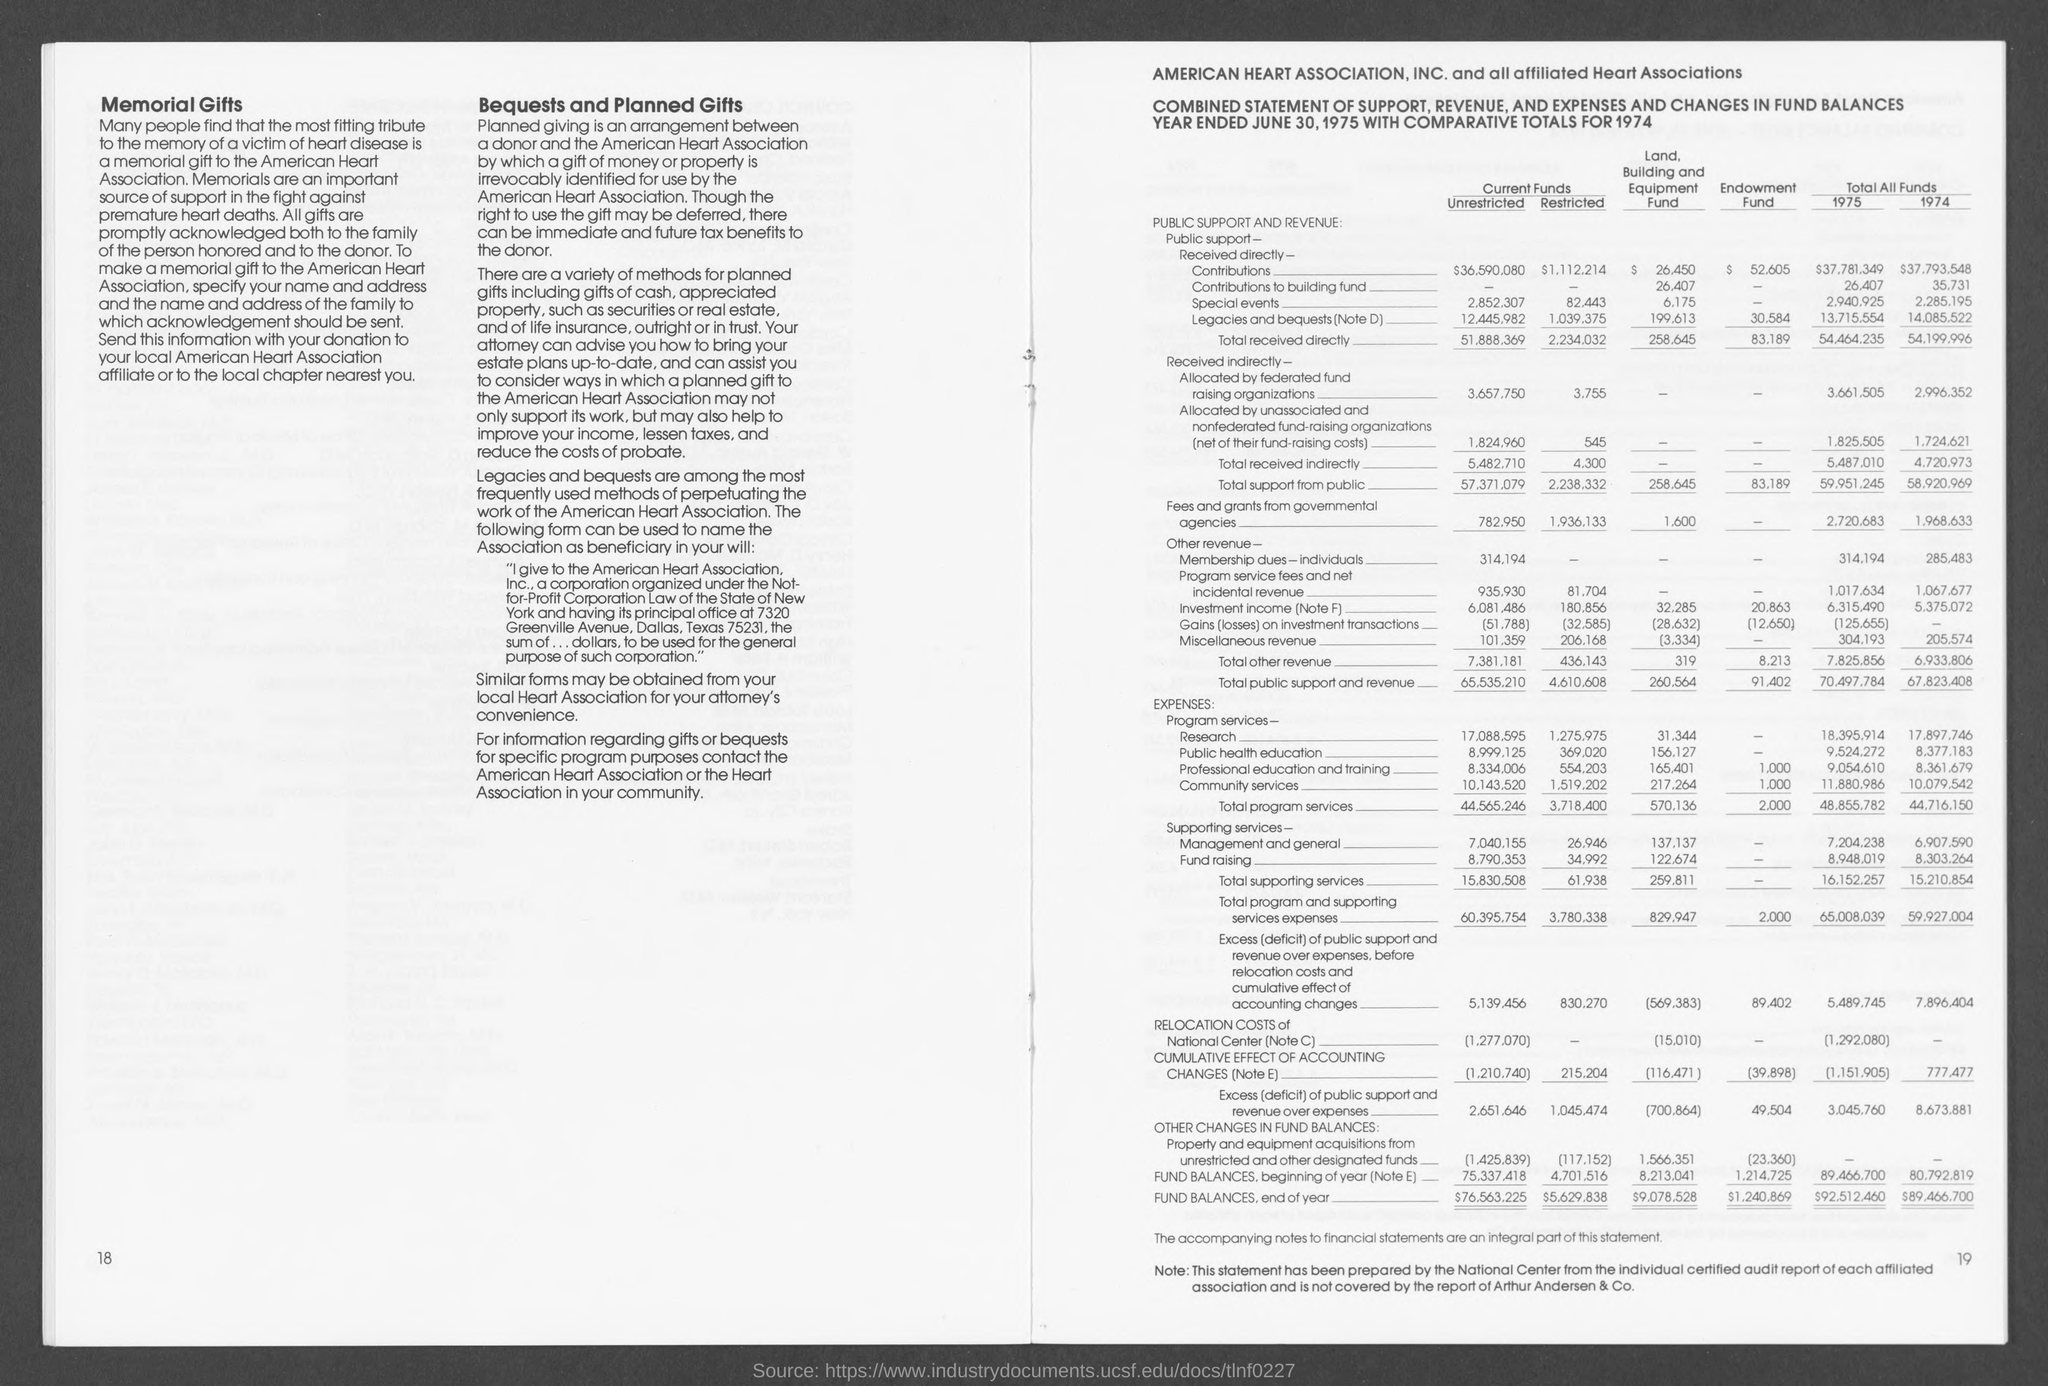Point out several critical features in this image. The total received directly unrestricted current funds is 51,888,369. The total amount of directly restricted current funds is 2,234,032. 